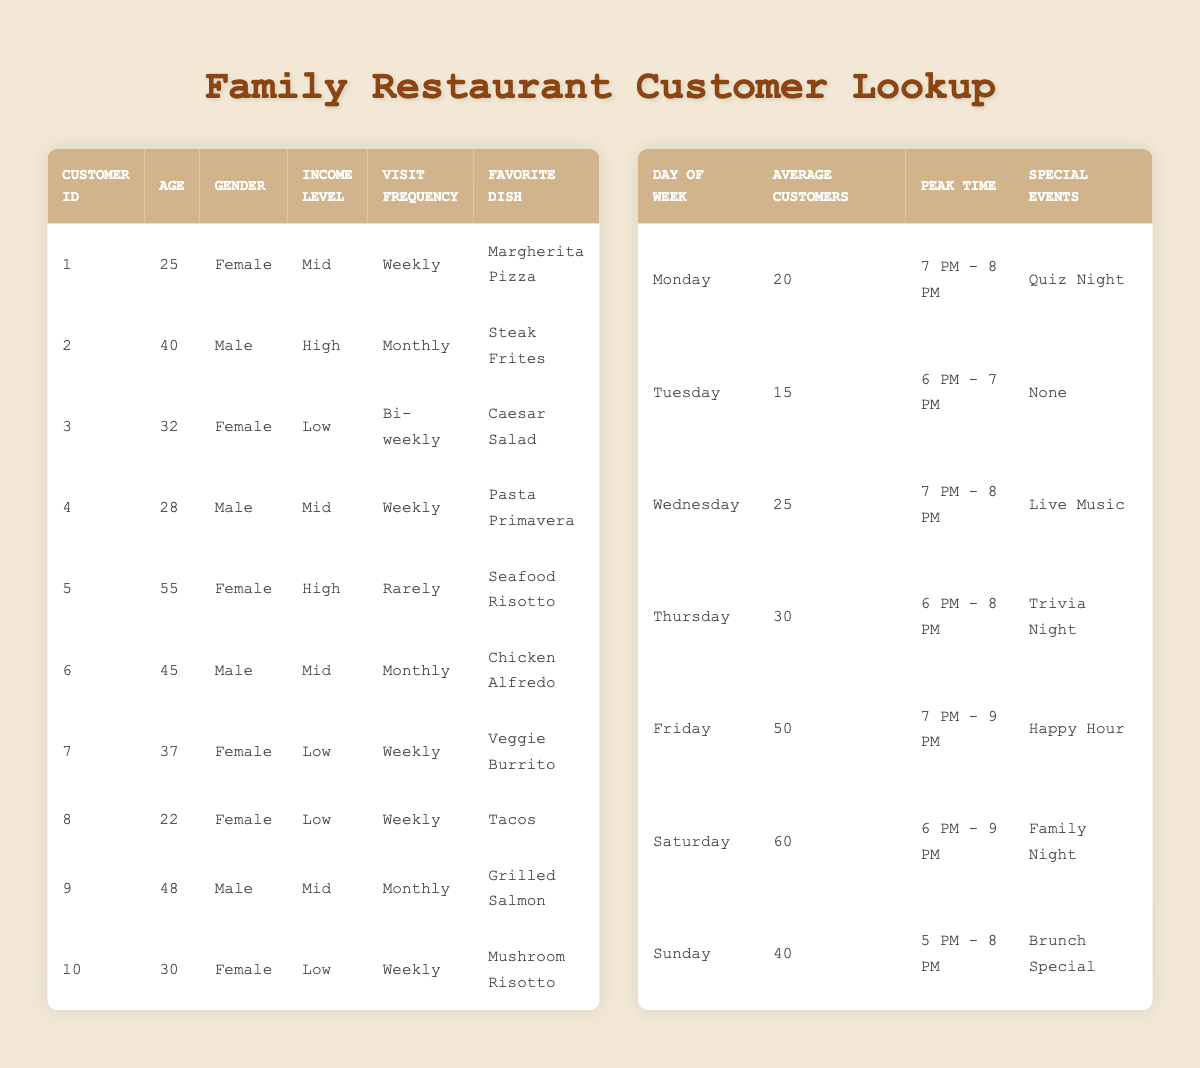What is the favorite dish of the customer with ID 3? The table shows that Customer ID 3 has the favorite dish listed as "Caesar Salad."
Answer: Caesar Salad How many customers visit the restaurant weekly? Looking at the data for visitation frequency, the customers listed as visiting weekly are Customers ID 1, 4, 7, 8, and 10, making a total of 5 customers.
Answer: 5 Which day has the highest average number of customers? The visitation patterns indicate that Saturday has the highest average number with 60 customers, compared to other days.
Answer: Saturday What is the average age of customers who have a high income level? The customers with a high income level are IDs 2 and 5 with ages 40 and 55, respectively. The sum is 40 + 55 = 95, and there are 2 customers, so the average age is 95/2 = 47.5.
Answer: 47.5 Are there any customers who visit the restaurant rarely? The data indicates that Customer ID 5 visits rarely, confirmed by its visitation frequency.
Answer: Yes What is the peak time for Friday's visitation? According to the visitation patterns, Friday's peak time for customers is from 7 PM to 9 PM.
Answer: 7 PM - 9 PM Which gender has more customers visiting weekly? From the weekly visits, females include ID 1, 7, 8, and 10 (totaling 4), while males include IDs 4. Thus, females have more weekly customers than males by a count of 4 to 1.
Answer: Female What income level does the customer who likes Mushroom Risotto belong to? Customer ID 10 has the favorite dish of "Mushroom Risotto" and is categorized under the low income level in the data.
Answer: Low On which day is there a special event, and what is it? The data indicates that Wednesday features "Live Music" as a special event, which is specific to that day.
Answer: Live Music 